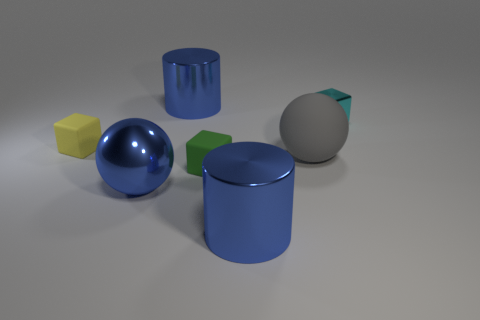Subtract all rubber blocks. How many blocks are left? 1 Add 3 matte things. How many objects exist? 10 Subtract all green cubes. How many cubes are left? 2 Subtract all cylinders. How many objects are left? 5 Subtract 0 yellow balls. How many objects are left? 7 Subtract all red cubes. Subtract all green spheres. How many cubes are left? 3 Subtract all yellow rubber things. Subtract all tiny yellow matte things. How many objects are left? 5 Add 4 tiny cyan blocks. How many tiny cyan blocks are left? 5 Add 4 gray metallic cylinders. How many gray metallic cylinders exist? 4 